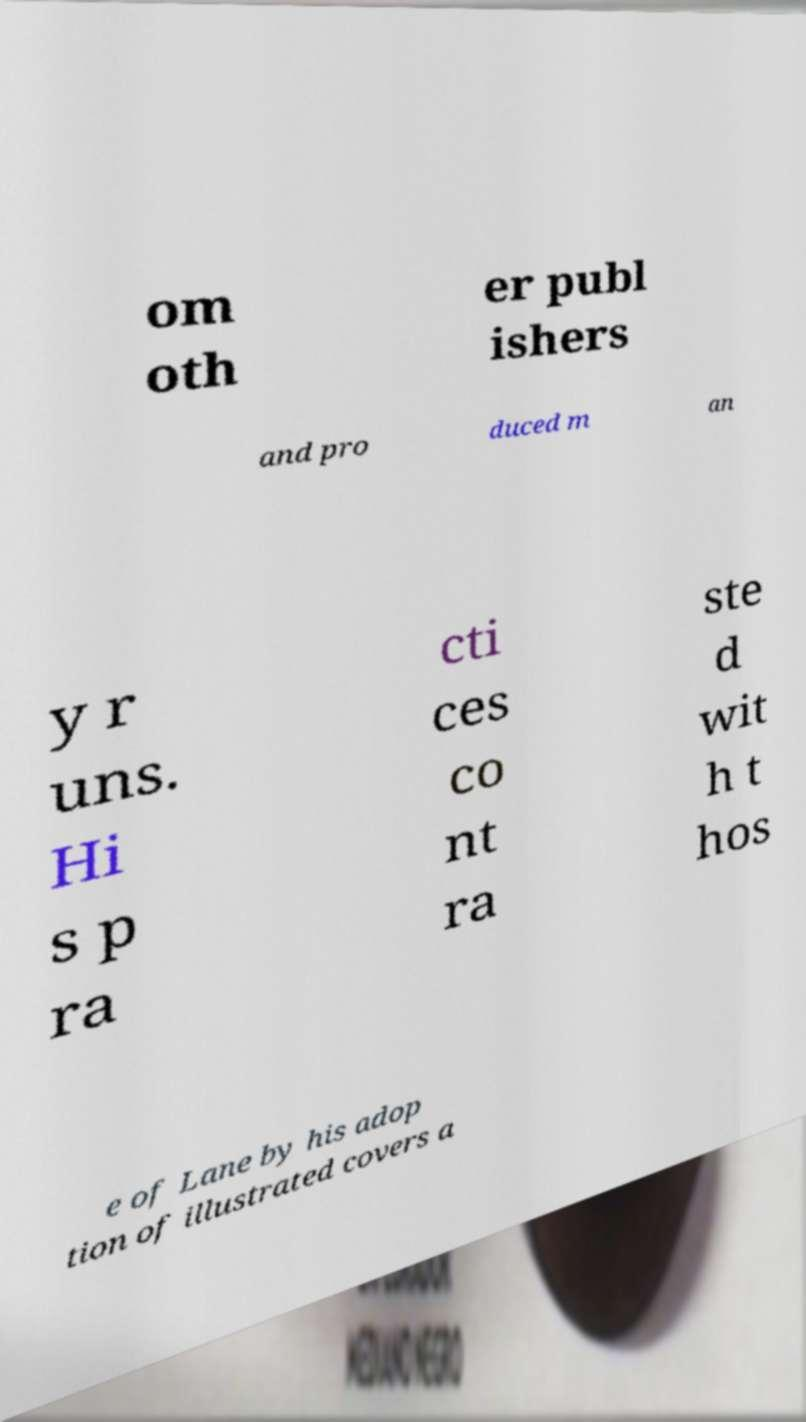There's text embedded in this image that I need extracted. Can you transcribe it verbatim? om oth er publ ishers and pro duced m an y r uns. Hi s p ra cti ces co nt ra ste d wit h t hos e of Lane by his adop tion of illustrated covers a 